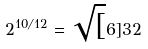<formula> <loc_0><loc_0><loc_500><loc_500>2 ^ { 1 0 / 1 2 } = \sqrt { [ } 6 ] { 3 2 }</formula> 